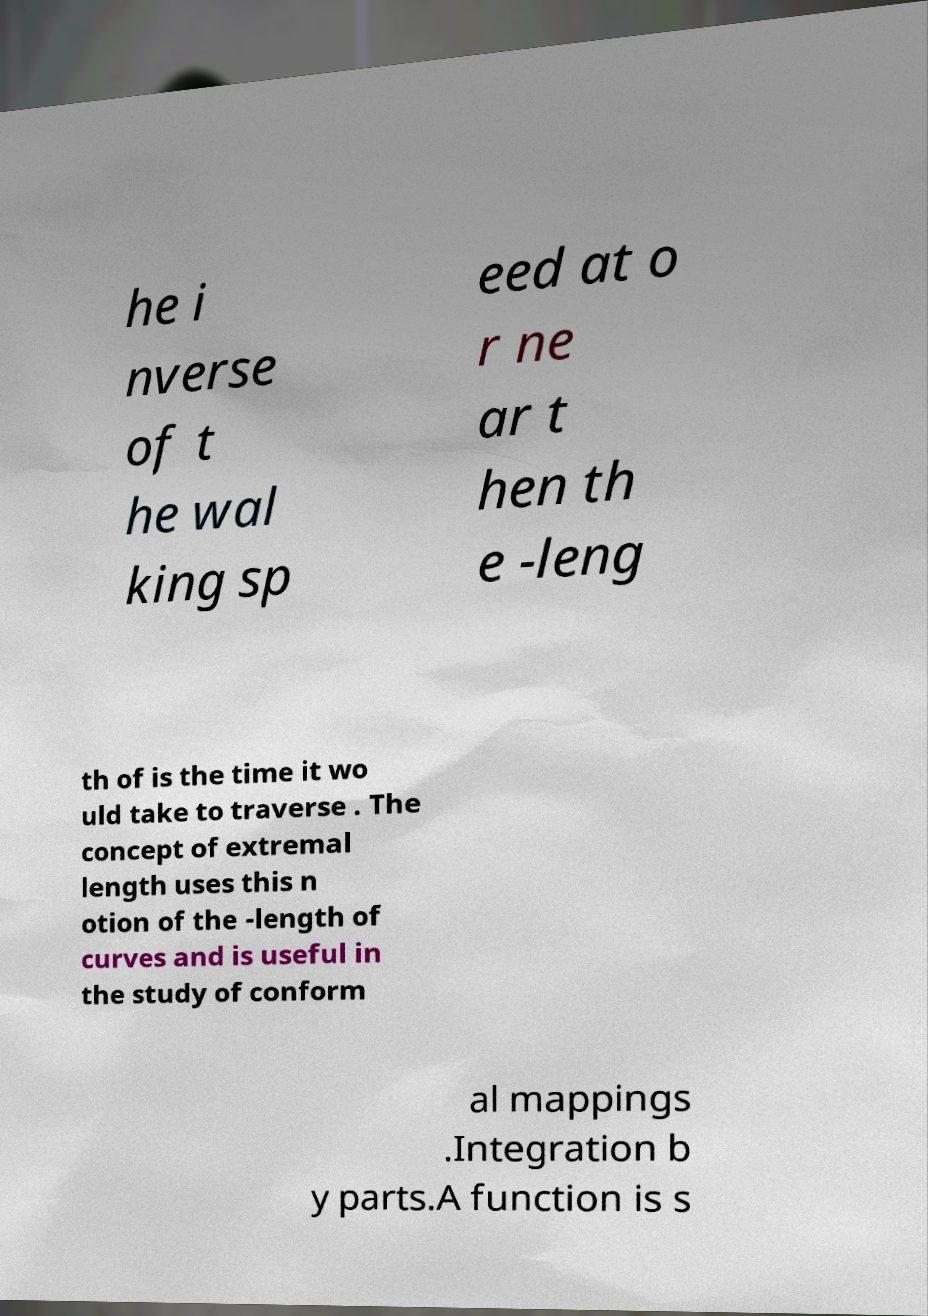Please read and relay the text visible in this image. What does it say? he i nverse of t he wal king sp eed at o r ne ar t hen th e -leng th of is the time it wo uld take to traverse . The concept of extremal length uses this n otion of the -length of curves and is useful in the study of conform al mappings .Integration b y parts.A function is s 